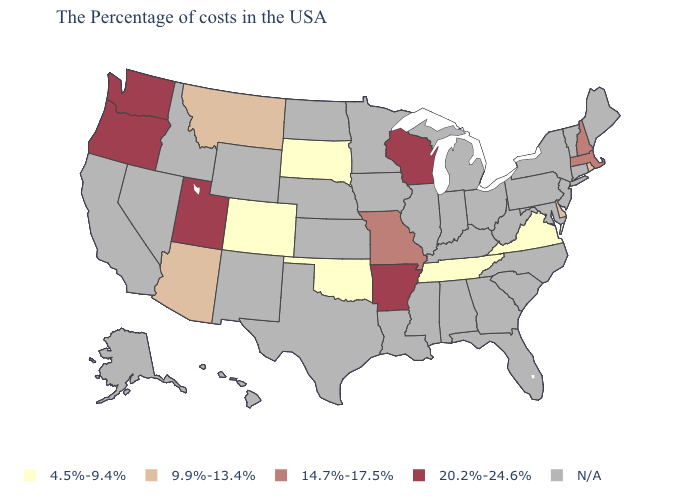Name the states that have a value in the range 14.7%-17.5%?
Give a very brief answer. Massachusetts, New Hampshire, Missouri. What is the value of Idaho?
Keep it brief. N/A. What is the value of Arkansas?
Keep it brief. 20.2%-24.6%. Name the states that have a value in the range 20.2%-24.6%?
Give a very brief answer. Wisconsin, Arkansas, Utah, Washington, Oregon. Does the map have missing data?
Answer briefly. Yes. Does the first symbol in the legend represent the smallest category?
Concise answer only. Yes. What is the value of New Jersey?
Quick response, please. N/A. Among the states that border Utah , does Arizona have the highest value?
Keep it brief. Yes. Name the states that have a value in the range 9.9%-13.4%?
Give a very brief answer. Rhode Island, Delaware, Montana, Arizona. What is the value of Missouri?
Short answer required. 14.7%-17.5%. What is the value of Kansas?
Short answer required. N/A. What is the lowest value in the South?
Quick response, please. 4.5%-9.4%. Name the states that have a value in the range 20.2%-24.6%?
Quick response, please. Wisconsin, Arkansas, Utah, Washington, Oregon. 